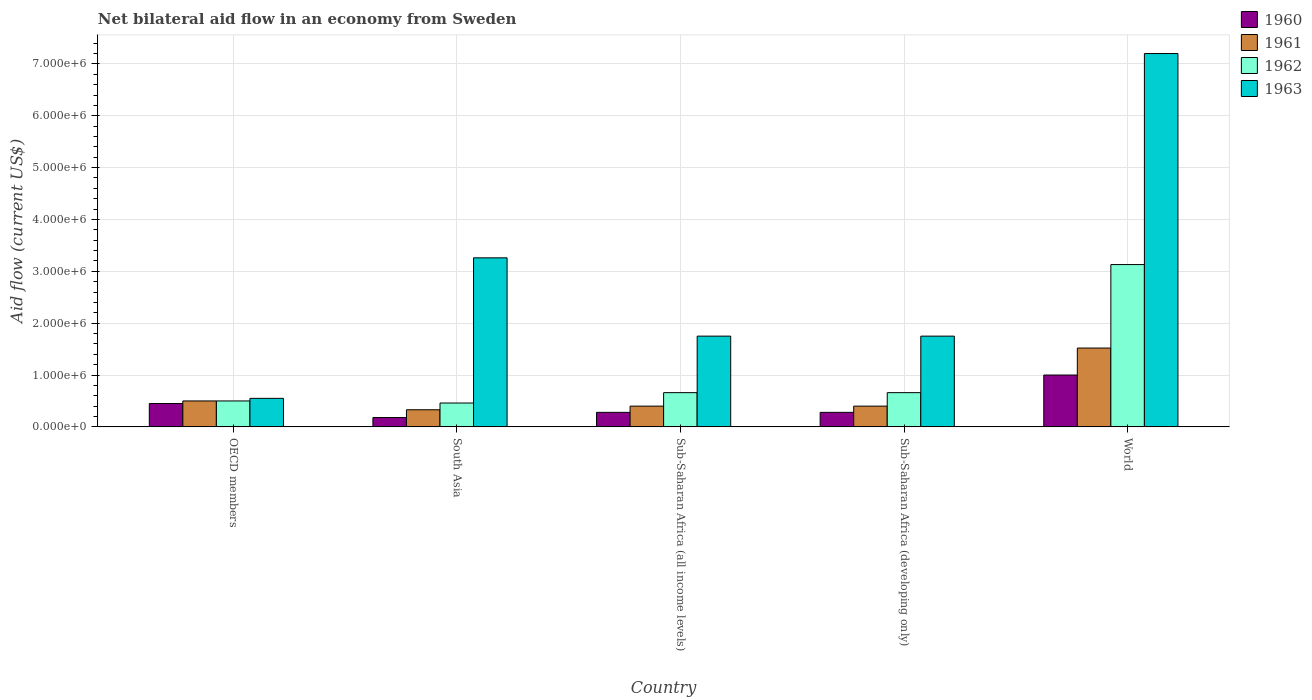How many different coloured bars are there?
Provide a short and direct response. 4. How many groups of bars are there?
Give a very brief answer. 5. In how many cases, is the number of bars for a given country not equal to the number of legend labels?
Give a very brief answer. 0. Across all countries, what is the maximum net bilateral aid flow in 1961?
Make the answer very short. 1.52e+06. Across all countries, what is the minimum net bilateral aid flow in 1961?
Your answer should be compact. 3.30e+05. In which country was the net bilateral aid flow in 1963 minimum?
Your response must be concise. OECD members. What is the total net bilateral aid flow in 1960 in the graph?
Keep it short and to the point. 2.19e+06. What is the difference between the net bilateral aid flow in 1960 in South Asia and that in World?
Keep it short and to the point. -8.20e+05. What is the difference between the net bilateral aid flow in 1962 in Sub-Saharan Africa (all income levels) and the net bilateral aid flow in 1963 in South Asia?
Ensure brevity in your answer.  -2.60e+06. What is the average net bilateral aid flow in 1960 per country?
Your answer should be very brief. 4.38e+05. What is the difference between the net bilateral aid flow of/in 1963 and net bilateral aid flow of/in 1960 in South Asia?
Provide a succinct answer. 3.08e+06. In how many countries, is the net bilateral aid flow in 1961 greater than 6800000 US$?
Provide a succinct answer. 0. What is the ratio of the net bilateral aid flow in 1961 in South Asia to that in Sub-Saharan Africa (developing only)?
Keep it short and to the point. 0.82. Is the net bilateral aid flow in 1962 in South Asia less than that in Sub-Saharan Africa (all income levels)?
Your answer should be compact. Yes. Is the difference between the net bilateral aid flow in 1963 in Sub-Saharan Africa (all income levels) and Sub-Saharan Africa (developing only) greater than the difference between the net bilateral aid flow in 1960 in Sub-Saharan Africa (all income levels) and Sub-Saharan Africa (developing only)?
Give a very brief answer. No. What is the difference between the highest and the second highest net bilateral aid flow in 1960?
Offer a terse response. 7.20e+05. What is the difference between the highest and the lowest net bilateral aid flow in 1962?
Your answer should be very brief. 2.67e+06. Is the sum of the net bilateral aid flow in 1963 in OECD members and World greater than the maximum net bilateral aid flow in 1960 across all countries?
Your response must be concise. Yes. Is it the case that in every country, the sum of the net bilateral aid flow in 1960 and net bilateral aid flow in 1962 is greater than the sum of net bilateral aid flow in 1961 and net bilateral aid flow in 1963?
Ensure brevity in your answer.  Yes. What does the 3rd bar from the left in OECD members represents?
Your answer should be compact. 1962. What does the 4th bar from the right in Sub-Saharan Africa (all income levels) represents?
Make the answer very short. 1960. How many bars are there?
Keep it short and to the point. 20. Are all the bars in the graph horizontal?
Your answer should be very brief. No. How many countries are there in the graph?
Give a very brief answer. 5. Are the values on the major ticks of Y-axis written in scientific E-notation?
Provide a short and direct response. Yes. Does the graph contain any zero values?
Give a very brief answer. No. How many legend labels are there?
Offer a very short reply. 4. What is the title of the graph?
Offer a very short reply. Net bilateral aid flow in an economy from Sweden. What is the label or title of the Y-axis?
Keep it short and to the point. Aid flow (current US$). What is the Aid flow (current US$) in 1961 in OECD members?
Your response must be concise. 5.00e+05. What is the Aid flow (current US$) in 1960 in South Asia?
Offer a very short reply. 1.80e+05. What is the Aid flow (current US$) of 1963 in South Asia?
Offer a terse response. 3.26e+06. What is the Aid flow (current US$) in 1960 in Sub-Saharan Africa (all income levels)?
Your response must be concise. 2.80e+05. What is the Aid flow (current US$) in 1961 in Sub-Saharan Africa (all income levels)?
Make the answer very short. 4.00e+05. What is the Aid flow (current US$) in 1963 in Sub-Saharan Africa (all income levels)?
Your answer should be very brief. 1.75e+06. What is the Aid flow (current US$) of 1960 in Sub-Saharan Africa (developing only)?
Offer a terse response. 2.80e+05. What is the Aid flow (current US$) in 1963 in Sub-Saharan Africa (developing only)?
Your answer should be compact. 1.75e+06. What is the Aid flow (current US$) of 1960 in World?
Offer a terse response. 1.00e+06. What is the Aid flow (current US$) in 1961 in World?
Make the answer very short. 1.52e+06. What is the Aid flow (current US$) in 1962 in World?
Make the answer very short. 3.13e+06. What is the Aid flow (current US$) of 1963 in World?
Ensure brevity in your answer.  7.20e+06. Across all countries, what is the maximum Aid flow (current US$) of 1960?
Make the answer very short. 1.00e+06. Across all countries, what is the maximum Aid flow (current US$) of 1961?
Provide a short and direct response. 1.52e+06. Across all countries, what is the maximum Aid flow (current US$) in 1962?
Offer a terse response. 3.13e+06. Across all countries, what is the maximum Aid flow (current US$) of 1963?
Give a very brief answer. 7.20e+06. Across all countries, what is the minimum Aid flow (current US$) of 1960?
Your answer should be very brief. 1.80e+05. What is the total Aid flow (current US$) in 1960 in the graph?
Keep it short and to the point. 2.19e+06. What is the total Aid flow (current US$) of 1961 in the graph?
Your answer should be compact. 3.15e+06. What is the total Aid flow (current US$) of 1962 in the graph?
Give a very brief answer. 5.41e+06. What is the total Aid flow (current US$) in 1963 in the graph?
Keep it short and to the point. 1.45e+07. What is the difference between the Aid flow (current US$) of 1963 in OECD members and that in South Asia?
Give a very brief answer. -2.71e+06. What is the difference between the Aid flow (current US$) of 1961 in OECD members and that in Sub-Saharan Africa (all income levels)?
Offer a very short reply. 1.00e+05. What is the difference between the Aid flow (current US$) of 1962 in OECD members and that in Sub-Saharan Africa (all income levels)?
Ensure brevity in your answer.  -1.60e+05. What is the difference between the Aid flow (current US$) of 1963 in OECD members and that in Sub-Saharan Africa (all income levels)?
Provide a succinct answer. -1.20e+06. What is the difference between the Aid flow (current US$) of 1961 in OECD members and that in Sub-Saharan Africa (developing only)?
Provide a succinct answer. 1.00e+05. What is the difference between the Aid flow (current US$) of 1962 in OECD members and that in Sub-Saharan Africa (developing only)?
Your answer should be compact. -1.60e+05. What is the difference between the Aid flow (current US$) of 1963 in OECD members and that in Sub-Saharan Africa (developing only)?
Keep it short and to the point. -1.20e+06. What is the difference between the Aid flow (current US$) in 1960 in OECD members and that in World?
Offer a very short reply. -5.50e+05. What is the difference between the Aid flow (current US$) in 1961 in OECD members and that in World?
Your answer should be very brief. -1.02e+06. What is the difference between the Aid flow (current US$) in 1962 in OECD members and that in World?
Your response must be concise. -2.63e+06. What is the difference between the Aid flow (current US$) in 1963 in OECD members and that in World?
Ensure brevity in your answer.  -6.65e+06. What is the difference between the Aid flow (current US$) of 1960 in South Asia and that in Sub-Saharan Africa (all income levels)?
Provide a succinct answer. -1.00e+05. What is the difference between the Aid flow (current US$) in 1961 in South Asia and that in Sub-Saharan Africa (all income levels)?
Provide a short and direct response. -7.00e+04. What is the difference between the Aid flow (current US$) of 1962 in South Asia and that in Sub-Saharan Africa (all income levels)?
Offer a terse response. -2.00e+05. What is the difference between the Aid flow (current US$) in 1963 in South Asia and that in Sub-Saharan Africa (all income levels)?
Provide a succinct answer. 1.51e+06. What is the difference between the Aid flow (current US$) in 1960 in South Asia and that in Sub-Saharan Africa (developing only)?
Your answer should be compact. -1.00e+05. What is the difference between the Aid flow (current US$) in 1961 in South Asia and that in Sub-Saharan Africa (developing only)?
Ensure brevity in your answer.  -7.00e+04. What is the difference between the Aid flow (current US$) of 1963 in South Asia and that in Sub-Saharan Africa (developing only)?
Your answer should be compact. 1.51e+06. What is the difference between the Aid flow (current US$) of 1960 in South Asia and that in World?
Offer a terse response. -8.20e+05. What is the difference between the Aid flow (current US$) of 1961 in South Asia and that in World?
Give a very brief answer. -1.19e+06. What is the difference between the Aid flow (current US$) of 1962 in South Asia and that in World?
Your answer should be compact. -2.67e+06. What is the difference between the Aid flow (current US$) in 1963 in South Asia and that in World?
Ensure brevity in your answer.  -3.94e+06. What is the difference between the Aid flow (current US$) of 1960 in Sub-Saharan Africa (all income levels) and that in Sub-Saharan Africa (developing only)?
Your answer should be very brief. 0. What is the difference between the Aid flow (current US$) of 1961 in Sub-Saharan Africa (all income levels) and that in Sub-Saharan Africa (developing only)?
Make the answer very short. 0. What is the difference between the Aid flow (current US$) of 1962 in Sub-Saharan Africa (all income levels) and that in Sub-Saharan Africa (developing only)?
Your response must be concise. 0. What is the difference between the Aid flow (current US$) in 1960 in Sub-Saharan Africa (all income levels) and that in World?
Your response must be concise. -7.20e+05. What is the difference between the Aid flow (current US$) of 1961 in Sub-Saharan Africa (all income levels) and that in World?
Keep it short and to the point. -1.12e+06. What is the difference between the Aid flow (current US$) of 1962 in Sub-Saharan Africa (all income levels) and that in World?
Keep it short and to the point. -2.47e+06. What is the difference between the Aid flow (current US$) in 1963 in Sub-Saharan Africa (all income levels) and that in World?
Keep it short and to the point. -5.45e+06. What is the difference between the Aid flow (current US$) in 1960 in Sub-Saharan Africa (developing only) and that in World?
Provide a short and direct response. -7.20e+05. What is the difference between the Aid flow (current US$) in 1961 in Sub-Saharan Africa (developing only) and that in World?
Ensure brevity in your answer.  -1.12e+06. What is the difference between the Aid flow (current US$) in 1962 in Sub-Saharan Africa (developing only) and that in World?
Give a very brief answer. -2.47e+06. What is the difference between the Aid flow (current US$) in 1963 in Sub-Saharan Africa (developing only) and that in World?
Make the answer very short. -5.45e+06. What is the difference between the Aid flow (current US$) in 1960 in OECD members and the Aid flow (current US$) in 1961 in South Asia?
Provide a short and direct response. 1.20e+05. What is the difference between the Aid flow (current US$) in 1960 in OECD members and the Aid flow (current US$) in 1963 in South Asia?
Make the answer very short. -2.81e+06. What is the difference between the Aid flow (current US$) in 1961 in OECD members and the Aid flow (current US$) in 1962 in South Asia?
Your answer should be very brief. 4.00e+04. What is the difference between the Aid flow (current US$) of 1961 in OECD members and the Aid flow (current US$) of 1963 in South Asia?
Ensure brevity in your answer.  -2.76e+06. What is the difference between the Aid flow (current US$) in 1962 in OECD members and the Aid flow (current US$) in 1963 in South Asia?
Your answer should be compact. -2.76e+06. What is the difference between the Aid flow (current US$) of 1960 in OECD members and the Aid flow (current US$) of 1961 in Sub-Saharan Africa (all income levels)?
Provide a short and direct response. 5.00e+04. What is the difference between the Aid flow (current US$) of 1960 in OECD members and the Aid flow (current US$) of 1962 in Sub-Saharan Africa (all income levels)?
Your answer should be very brief. -2.10e+05. What is the difference between the Aid flow (current US$) in 1960 in OECD members and the Aid flow (current US$) in 1963 in Sub-Saharan Africa (all income levels)?
Provide a succinct answer. -1.30e+06. What is the difference between the Aid flow (current US$) in 1961 in OECD members and the Aid flow (current US$) in 1962 in Sub-Saharan Africa (all income levels)?
Ensure brevity in your answer.  -1.60e+05. What is the difference between the Aid flow (current US$) of 1961 in OECD members and the Aid flow (current US$) of 1963 in Sub-Saharan Africa (all income levels)?
Give a very brief answer. -1.25e+06. What is the difference between the Aid flow (current US$) in 1962 in OECD members and the Aid flow (current US$) in 1963 in Sub-Saharan Africa (all income levels)?
Your answer should be compact. -1.25e+06. What is the difference between the Aid flow (current US$) in 1960 in OECD members and the Aid flow (current US$) in 1961 in Sub-Saharan Africa (developing only)?
Your answer should be very brief. 5.00e+04. What is the difference between the Aid flow (current US$) in 1960 in OECD members and the Aid flow (current US$) in 1962 in Sub-Saharan Africa (developing only)?
Give a very brief answer. -2.10e+05. What is the difference between the Aid flow (current US$) in 1960 in OECD members and the Aid flow (current US$) in 1963 in Sub-Saharan Africa (developing only)?
Your response must be concise. -1.30e+06. What is the difference between the Aid flow (current US$) in 1961 in OECD members and the Aid flow (current US$) in 1962 in Sub-Saharan Africa (developing only)?
Your answer should be very brief. -1.60e+05. What is the difference between the Aid flow (current US$) of 1961 in OECD members and the Aid flow (current US$) of 1963 in Sub-Saharan Africa (developing only)?
Your response must be concise. -1.25e+06. What is the difference between the Aid flow (current US$) of 1962 in OECD members and the Aid flow (current US$) of 1963 in Sub-Saharan Africa (developing only)?
Offer a very short reply. -1.25e+06. What is the difference between the Aid flow (current US$) in 1960 in OECD members and the Aid flow (current US$) in 1961 in World?
Provide a short and direct response. -1.07e+06. What is the difference between the Aid flow (current US$) of 1960 in OECD members and the Aid flow (current US$) of 1962 in World?
Offer a very short reply. -2.68e+06. What is the difference between the Aid flow (current US$) of 1960 in OECD members and the Aid flow (current US$) of 1963 in World?
Provide a short and direct response. -6.75e+06. What is the difference between the Aid flow (current US$) in 1961 in OECD members and the Aid flow (current US$) in 1962 in World?
Ensure brevity in your answer.  -2.63e+06. What is the difference between the Aid flow (current US$) in 1961 in OECD members and the Aid flow (current US$) in 1963 in World?
Offer a terse response. -6.70e+06. What is the difference between the Aid flow (current US$) in 1962 in OECD members and the Aid flow (current US$) in 1963 in World?
Provide a succinct answer. -6.70e+06. What is the difference between the Aid flow (current US$) in 1960 in South Asia and the Aid flow (current US$) in 1962 in Sub-Saharan Africa (all income levels)?
Keep it short and to the point. -4.80e+05. What is the difference between the Aid flow (current US$) in 1960 in South Asia and the Aid flow (current US$) in 1963 in Sub-Saharan Africa (all income levels)?
Give a very brief answer. -1.57e+06. What is the difference between the Aid flow (current US$) in 1961 in South Asia and the Aid flow (current US$) in 1962 in Sub-Saharan Africa (all income levels)?
Provide a short and direct response. -3.30e+05. What is the difference between the Aid flow (current US$) in 1961 in South Asia and the Aid flow (current US$) in 1963 in Sub-Saharan Africa (all income levels)?
Ensure brevity in your answer.  -1.42e+06. What is the difference between the Aid flow (current US$) of 1962 in South Asia and the Aid flow (current US$) of 1963 in Sub-Saharan Africa (all income levels)?
Provide a succinct answer. -1.29e+06. What is the difference between the Aid flow (current US$) in 1960 in South Asia and the Aid flow (current US$) in 1961 in Sub-Saharan Africa (developing only)?
Offer a terse response. -2.20e+05. What is the difference between the Aid flow (current US$) in 1960 in South Asia and the Aid flow (current US$) in 1962 in Sub-Saharan Africa (developing only)?
Make the answer very short. -4.80e+05. What is the difference between the Aid flow (current US$) in 1960 in South Asia and the Aid flow (current US$) in 1963 in Sub-Saharan Africa (developing only)?
Ensure brevity in your answer.  -1.57e+06. What is the difference between the Aid flow (current US$) of 1961 in South Asia and the Aid flow (current US$) of 1962 in Sub-Saharan Africa (developing only)?
Your response must be concise. -3.30e+05. What is the difference between the Aid flow (current US$) in 1961 in South Asia and the Aid flow (current US$) in 1963 in Sub-Saharan Africa (developing only)?
Make the answer very short. -1.42e+06. What is the difference between the Aid flow (current US$) in 1962 in South Asia and the Aid flow (current US$) in 1963 in Sub-Saharan Africa (developing only)?
Offer a very short reply. -1.29e+06. What is the difference between the Aid flow (current US$) in 1960 in South Asia and the Aid flow (current US$) in 1961 in World?
Ensure brevity in your answer.  -1.34e+06. What is the difference between the Aid flow (current US$) in 1960 in South Asia and the Aid flow (current US$) in 1962 in World?
Offer a terse response. -2.95e+06. What is the difference between the Aid flow (current US$) of 1960 in South Asia and the Aid flow (current US$) of 1963 in World?
Your answer should be very brief. -7.02e+06. What is the difference between the Aid flow (current US$) in 1961 in South Asia and the Aid flow (current US$) in 1962 in World?
Provide a short and direct response. -2.80e+06. What is the difference between the Aid flow (current US$) in 1961 in South Asia and the Aid flow (current US$) in 1963 in World?
Keep it short and to the point. -6.87e+06. What is the difference between the Aid flow (current US$) in 1962 in South Asia and the Aid flow (current US$) in 1963 in World?
Your response must be concise. -6.74e+06. What is the difference between the Aid flow (current US$) of 1960 in Sub-Saharan Africa (all income levels) and the Aid flow (current US$) of 1962 in Sub-Saharan Africa (developing only)?
Offer a terse response. -3.80e+05. What is the difference between the Aid flow (current US$) of 1960 in Sub-Saharan Africa (all income levels) and the Aid flow (current US$) of 1963 in Sub-Saharan Africa (developing only)?
Your answer should be very brief. -1.47e+06. What is the difference between the Aid flow (current US$) of 1961 in Sub-Saharan Africa (all income levels) and the Aid flow (current US$) of 1962 in Sub-Saharan Africa (developing only)?
Give a very brief answer. -2.60e+05. What is the difference between the Aid flow (current US$) of 1961 in Sub-Saharan Africa (all income levels) and the Aid flow (current US$) of 1963 in Sub-Saharan Africa (developing only)?
Ensure brevity in your answer.  -1.35e+06. What is the difference between the Aid flow (current US$) in 1962 in Sub-Saharan Africa (all income levels) and the Aid flow (current US$) in 1963 in Sub-Saharan Africa (developing only)?
Your answer should be very brief. -1.09e+06. What is the difference between the Aid flow (current US$) of 1960 in Sub-Saharan Africa (all income levels) and the Aid flow (current US$) of 1961 in World?
Keep it short and to the point. -1.24e+06. What is the difference between the Aid flow (current US$) of 1960 in Sub-Saharan Africa (all income levels) and the Aid flow (current US$) of 1962 in World?
Offer a very short reply. -2.85e+06. What is the difference between the Aid flow (current US$) in 1960 in Sub-Saharan Africa (all income levels) and the Aid flow (current US$) in 1963 in World?
Provide a succinct answer. -6.92e+06. What is the difference between the Aid flow (current US$) in 1961 in Sub-Saharan Africa (all income levels) and the Aid flow (current US$) in 1962 in World?
Your response must be concise. -2.73e+06. What is the difference between the Aid flow (current US$) in 1961 in Sub-Saharan Africa (all income levels) and the Aid flow (current US$) in 1963 in World?
Ensure brevity in your answer.  -6.80e+06. What is the difference between the Aid flow (current US$) in 1962 in Sub-Saharan Africa (all income levels) and the Aid flow (current US$) in 1963 in World?
Provide a succinct answer. -6.54e+06. What is the difference between the Aid flow (current US$) in 1960 in Sub-Saharan Africa (developing only) and the Aid flow (current US$) in 1961 in World?
Your answer should be compact. -1.24e+06. What is the difference between the Aid flow (current US$) of 1960 in Sub-Saharan Africa (developing only) and the Aid flow (current US$) of 1962 in World?
Make the answer very short. -2.85e+06. What is the difference between the Aid flow (current US$) of 1960 in Sub-Saharan Africa (developing only) and the Aid flow (current US$) of 1963 in World?
Offer a very short reply. -6.92e+06. What is the difference between the Aid flow (current US$) in 1961 in Sub-Saharan Africa (developing only) and the Aid flow (current US$) in 1962 in World?
Keep it short and to the point. -2.73e+06. What is the difference between the Aid flow (current US$) in 1961 in Sub-Saharan Africa (developing only) and the Aid flow (current US$) in 1963 in World?
Keep it short and to the point. -6.80e+06. What is the difference between the Aid flow (current US$) of 1962 in Sub-Saharan Africa (developing only) and the Aid flow (current US$) of 1963 in World?
Provide a short and direct response. -6.54e+06. What is the average Aid flow (current US$) of 1960 per country?
Your response must be concise. 4.38e+05. What is the average Aid flow (current US$) in 1961 per country?
Your answer should be very brief. 6.30e+05. What is the average Aid flow (current US$) of 1962 per country?
Your response must be concise. 1.08e+06. What is the average Aid flow (current US$) in 1963 per country?
Your response must be concise. 2.90e+06. What is the difference between the Aid flow (current US$) in 1960 and Aid flow (current US$) in 1961 in OECD members?
Your answer should be very brief. -5.00e+04. What is the difference between the Aid flow (current US$) in 1960 and Aid flow (current US$) in 1962 in OECD members?
Provide a succinct answer. -5.00e+04. What is the difference between the Aid flow (current US$) of 1961 and Aid flow (current US$) of 1962 in OECD members?
Provide a short and direct response. 0. What is the difference between the Aid flow (current US$) in 1961 and Aid flow (current US$) in 1963 in OECD members?
Make the answer very short. -5.00e+04. What is the difference between the Aid flow (current US$) of 1960 and Aid flow (current US$) of 1962 in South Asia?
Ensure brevity in your answer.  -2.80e+05. What is the difference between the Aid flow (current US$) in 1960 and Aid flow (current US$) in 1963 in South Asia?
Your response must be concise. -3.08e+06. What is the difference between the Aid flow (current US$) of 1961 and Aid flow (current US$) of 1963 in South Asia?
Make the answer very short. -2.93e+06. What is the difference between the Aid flow (current US$) in 1962 and Aid flow (current US$) in 1963 in South Asia?
Give a very brief answer. -2.80e+06. What is the difference between the Aid flow (current US$) in 1960 and Aid flow (current US$) in 1961 in Sub-Saharan Africa (all income levels)?
Your answer should be very brief. -1.20e+05. What is the difference between the Aid flow (current US$) in 1960 and Aid flow (current US$) in 1962 in Sub-Saharan Africa (all income levels)?
Offer a terse response. -3.80e+05. What is the difference between the Aid flow (current US$) of 1960 and Aid flow (current US$) of 1963 in Sub-Saharan Africa (all income levels)?
Give a very brief answer. -1.47e+06. What is the difference between the Aid flow (current US$) of 1961 and Aid flow (current US$) of 1963 in Sub-Saharan Africa (all income levels)?
Keep it short and to the point. -1.35e+06. What is the difference between the Aid flow (current US$) in 1962 and Aid flow (current US$) in 1963 in Sub-Saharan Africa (all income levels)?
Provide a short and direct response. -1.09e+06. What is the difference between the Aid flow (current US$) in 1960 and Aid flow (current US$) in 1962 in Sub-Saharan Africa (developing only)?
Give a very brief answer. -3.80e+05. What is the difference between the Aid flow (current US$) of 1960 and Aid flow (current US$) of 1963 in Sub-Saharan Africa (developing only)?
Give a very brief answer. -1.47e+06. What is the difference between the Aid flow (current US$) in 1961 and Aid flow (current US$) in 1963 in Sub-Saharan Africa (developing only)?
Your answer should be very brief. -1.35e+06. What is the difference between the Aid flow (current US$) in 1962 and Aid flow (current US$) in 1963 in Sub-Saharan Africa (developing only)?
Provide a succinct answer. -1.09e+06. What is the difference between the Aid flow (current US$) of 1960 and Aid flow (current US$) of 1961 in World?
Make the answer very short. -5.20e+05. What is the difference between the Aid flow (current US$) in 1960 and Aid flow (current US$) in 1962 in World?
Give a very brief answer. -2.13e+06. What is the difference between the Aid flow (current US$) of 1960 and Aid flow (current US$) of 1963 in World?
Your answer should be compact. -6.20e+06. What is the difference between the Aid flow (current US$) of 1961 and Aid flow (current US$) of 1962 in World?
Provide a short and direct response. -1.61e+06. What is the difference between the Aid flow (current US$) in 1961 and Aid flow (current US$) in 1963 in World?
Keep it short and to the point. -5.68e+06. What is the difference between the Aid flow (current US$) in 1962 and Aid flow (current US$) in 1963 in World?
Your answer should be compact. -4.07e+06. What is the ratio of the Aid flow (current US$) in 1960 in OECD members to that in South Asia?
Provide a succinct answer. 2.5. What is the ratio of the Aid flow (current US$) in 1961 in OECD members to that in South Asia?
Ensure brevity in your answer.  1.52. What is the ratio of the Aid flow (current US$) in 1962 in OECD members to that in South Asia?
Your response must be concise. 1.09. What is the ratio of the Aid flow (current US$) of 1963 in OECD members to that in South Asia?
Offer a very short reply. 0.17. What is the ratio of the Aid flow (current US$) of 1960 in OECD members to that in Sub-Saharan Africa (all income levels)?
Make the answer very short. 1.61. What is the ratio of the Aid flow (current US$) of 1961 in OECD members to that in Sub-Saharan Africa (all income levels)?
Provide a short and direct response. 1.25. What is the ratio of the Aid flow (current US$) in 1962 in OECD members to that in Sub-Saharan Africa (all income levels)?
Your answer should be very brief. 0.76. What is the ratio of the Aid flow (current US$) in 1963 in OECD members to that in Sub-Saharan Africa (all income levels)?
Your answer should be compact. 0.31. What is the ratio of the Aid flow (current US$) in 1960 in OECD members to that in Sub-Saharan Africa (developing only)?
Make the answer very short. 1.61. What is the ratio of the Aid flow (current US$) in 1961 in OECD members to that in Sub-Saharan Africa (developing only)?
Provide a succinct answer. 1.25. What is the ratio of the Aid flow (current US$) of 1962 in OECD members to that in Sub-Saharan Africa (developing only)?
Provide a short and direct response. 0.76. What is the ratio of the Aid flow (current US$) of 1963 in OECD members to that in Sub-Saharan Africa (developing only)?
Your answer should be compact. 0.31. What is the ratio of the Aid flow (current US$) of 1960 in OECD members to that in World?
Keep it short and to the point. 0.45. What is the ratio of the Aid flow (current US$) in 1961 in OECD members to that in World?
Ensure brevity in your answer.  0.33. What is the ratio of the Aid flow (current US$) of 1962 in OECD members to that in World?
Your response must be concise. 0.16. What is the ratio of the Aid flow (current US$) in 1963 in OECD members to that in World?
Your answer should be very brief. 0.08. What is the ratio of the Aid flow (current US$) in 1960 in South Asia to that in Sub-Saharan Africa (all income levels)?
Offer a terse response. 0.64. What is the ratio of the Aid flow (current US$) in 1961 in South Asia to that in Sub-Saharan Africa (all income levels)?
Ensure brevity in your answer.  0.82. What is the ratio of the Aid flow (current US$) in 1962 in South Asia to that in Sub-Saharan Africa (all income levels)?
Offer a very short reply. 0.7. What is the ratio of the Aid flow (current US$) in 1963 in South Asia to that in Sub-Saharan Africa (all income levels)?
Give a very brief answer. 1.86. What is the ratio of the Aid flow (current US$) in 1960 in South Asia to that in Sub-Saharan Africa (developing only)?
Your response must be concise. 0.64. What is the ratio of the Aid flow (current US$) in 1961 in South Asia to that in Sub-Saharan Africa (developing only)?
Provide a succinct answer. 0.82. What is the ratio of the Aid flow (current US$) in 1962 in South Asia to that in Sub-Saharan Africa (developing only)?
Your answer should be compact. 0.7. What is the ratio of the Aid flow (current US$) in 1963 in South Asia to that in Sub-Saharan Africa (developing only)?
Offer a terse response. 1.86. What is the ratio of the Aid flow (current US$) of 1960 in South Asia to that in World?
Offer a terse response. 0.18. What is the ratio of the Aid flow (current US$) in 1961 in South Asia to that in World?
Your response must be concise. 0.22. What is the ratio of the Aid flow (current US$) in 1962 in South Asia to that in World?
Provide a short and direct response. 0.15. What is the ratio of the Aid flow (current US$) in 1963 in South Asia to that in World?
Give a very brief answer. 0.45. What is the ratio of the Aid flow (current US$) in 1960 in Sub-Saharan Africa (all income levels) to that in Sub-Saharan Africa (developing only)?
Your answer should be very brief. 1. What is the ratio of the Aid flow (current US$) in 1962 in Sub-Saharan Africa (all income levels) to that in Sub-Saharan Africa (developing only)?
Your answer should be very brief. 1. What is the ratio of the Aid flow (current US$) in 1963 in Sub-Saharan Africa (all income levels) to that in Sub-Saharan Africa (developing only)?
Provide a succinct answer. 1. What is the ratio of the Aid flow (current US$) in 1960 in Sub-Saharan Africa (all income levels) to that in World?
Keep it short and to the point. 0.28. What is the ratio of the Aid flow (current US$) of 1961 in Sub-Saharan Africa (all income levels) to that in World?
Your answer should be compact. 0.26. What is the ratio of the Aid flow (current US$) of 1962 in Sub-Saharan Africa (all income levels) to that in World?
Offer a terse response. 0.21. What is the ratio of the Aid flow (current US$) in 1963 in Sub-Saharan Africa (all income levels) to that in World?
Ensure brevity in your answer.  0.24. What is the ratio of the Aid flow (current US$) of 1960 in Sub-Saharan Africa (developing only) to that in World?
Provide a succinct answer. 0.28. What is the ratio of the Aid flow (current US$) in 1961 in Sub-Saharan Africa (developing only) to that in World?
Your answer should be compact. 0.26. What is the ratio of the Aid flow (current US$) of 1962 in Sub-Saharan Africa (developing only) to that in World?
Offer a very short reply. 0.21. What is the ratio of the Aid flow (current US$) in 1963 in Sub-Saharan Africa (developing only) to that in World?
Your answer should be very brief. 0.24. What is the difference between the highest and the second highest Aid flow (current US$) in 1960?
Provide a short and direct response. 5.50e+05. What is the difference between the highest and the second highest Aid flow (current US$) in 1961?
Give a very brief answer. 1.02e+06. What is the difference between the highest and the second highest Aid flow (current US$) in 1962?
Offer a very short reply. 2.47e+06. What is the difference between the highest and the second highest Aid flow (current US$) of 1963?
Make the answer very short. 3.94e+06. What is the difference between the highest and the lowest Aid flow (current US$) in 1960?
Your answer should be very brief. 8.20e+05. What is the difference between the highest and the lowest Aid flow (current US$) in 1961?
Keep it short and to the point. 1.19e+06. What is the difference between the highest and the lowest Aid flow (current US$) of 1962?
Ensure brevity in your answer.  2.67e+06. What is the difference between the highest and the lowest Aid flow (current US$) of 1963?
Give a very brief answer. 6.65e+06. 